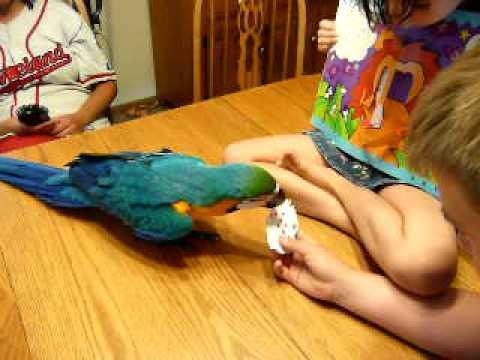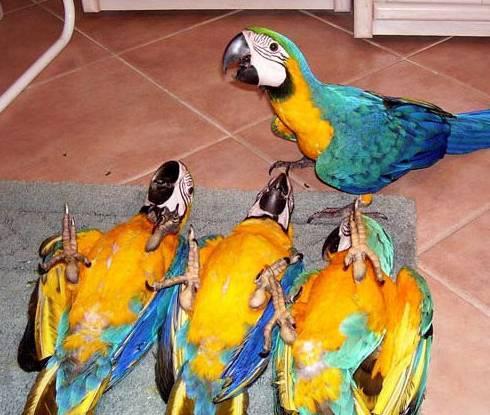The first image is the image on the left, the second image is the image on the right. For the images displayed, is the sentence "All birds shown have blue and yellow coloring, and at least one bird has its yellow belly facing the camera." factually correct? Answer yes or no. Yes. The first image is the image on the left, the second image is the image on the right. Analyze the images presented: Is the assertion "Two parrots nuzzle, in the image on the right." valid? Answer yes or no. No. 